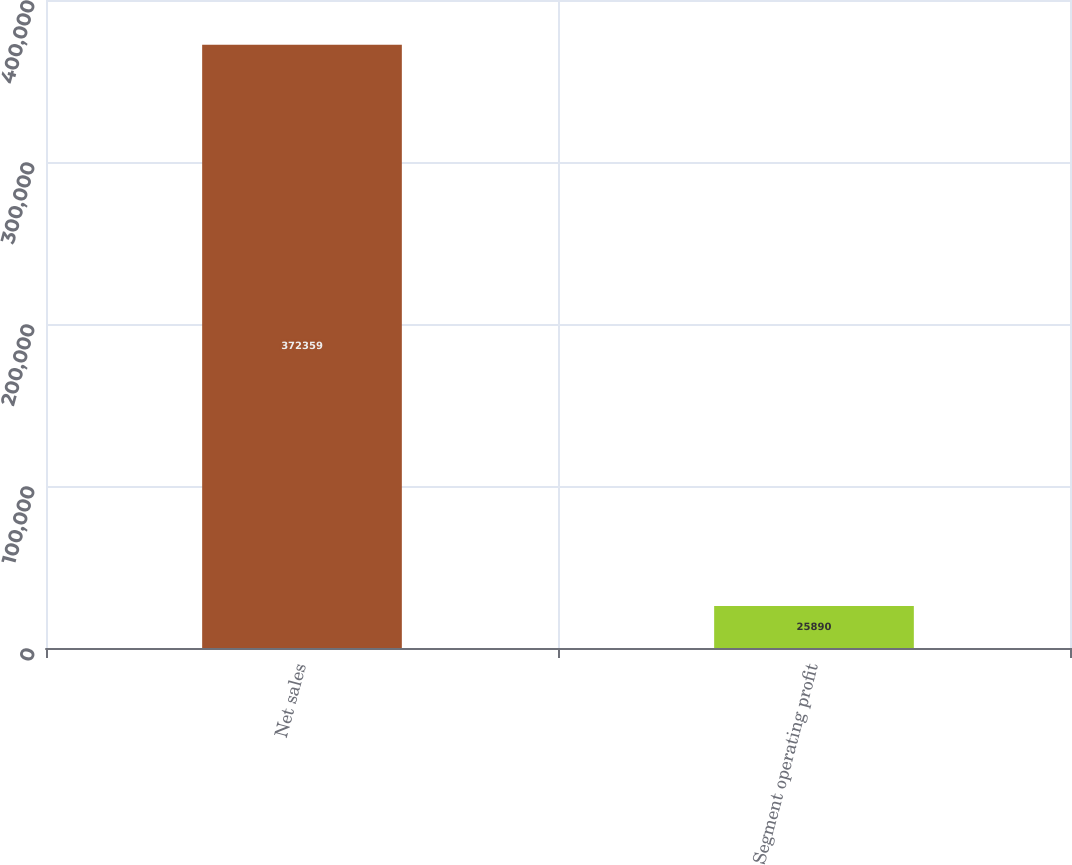Convert chart. <chart><loc_0><loc_0><loc_500><loc_500><bar_chart><fcel>Net sales<fcel>Segment operating profit<nl><fcel>372359<fcel>25890<nl></chart> 